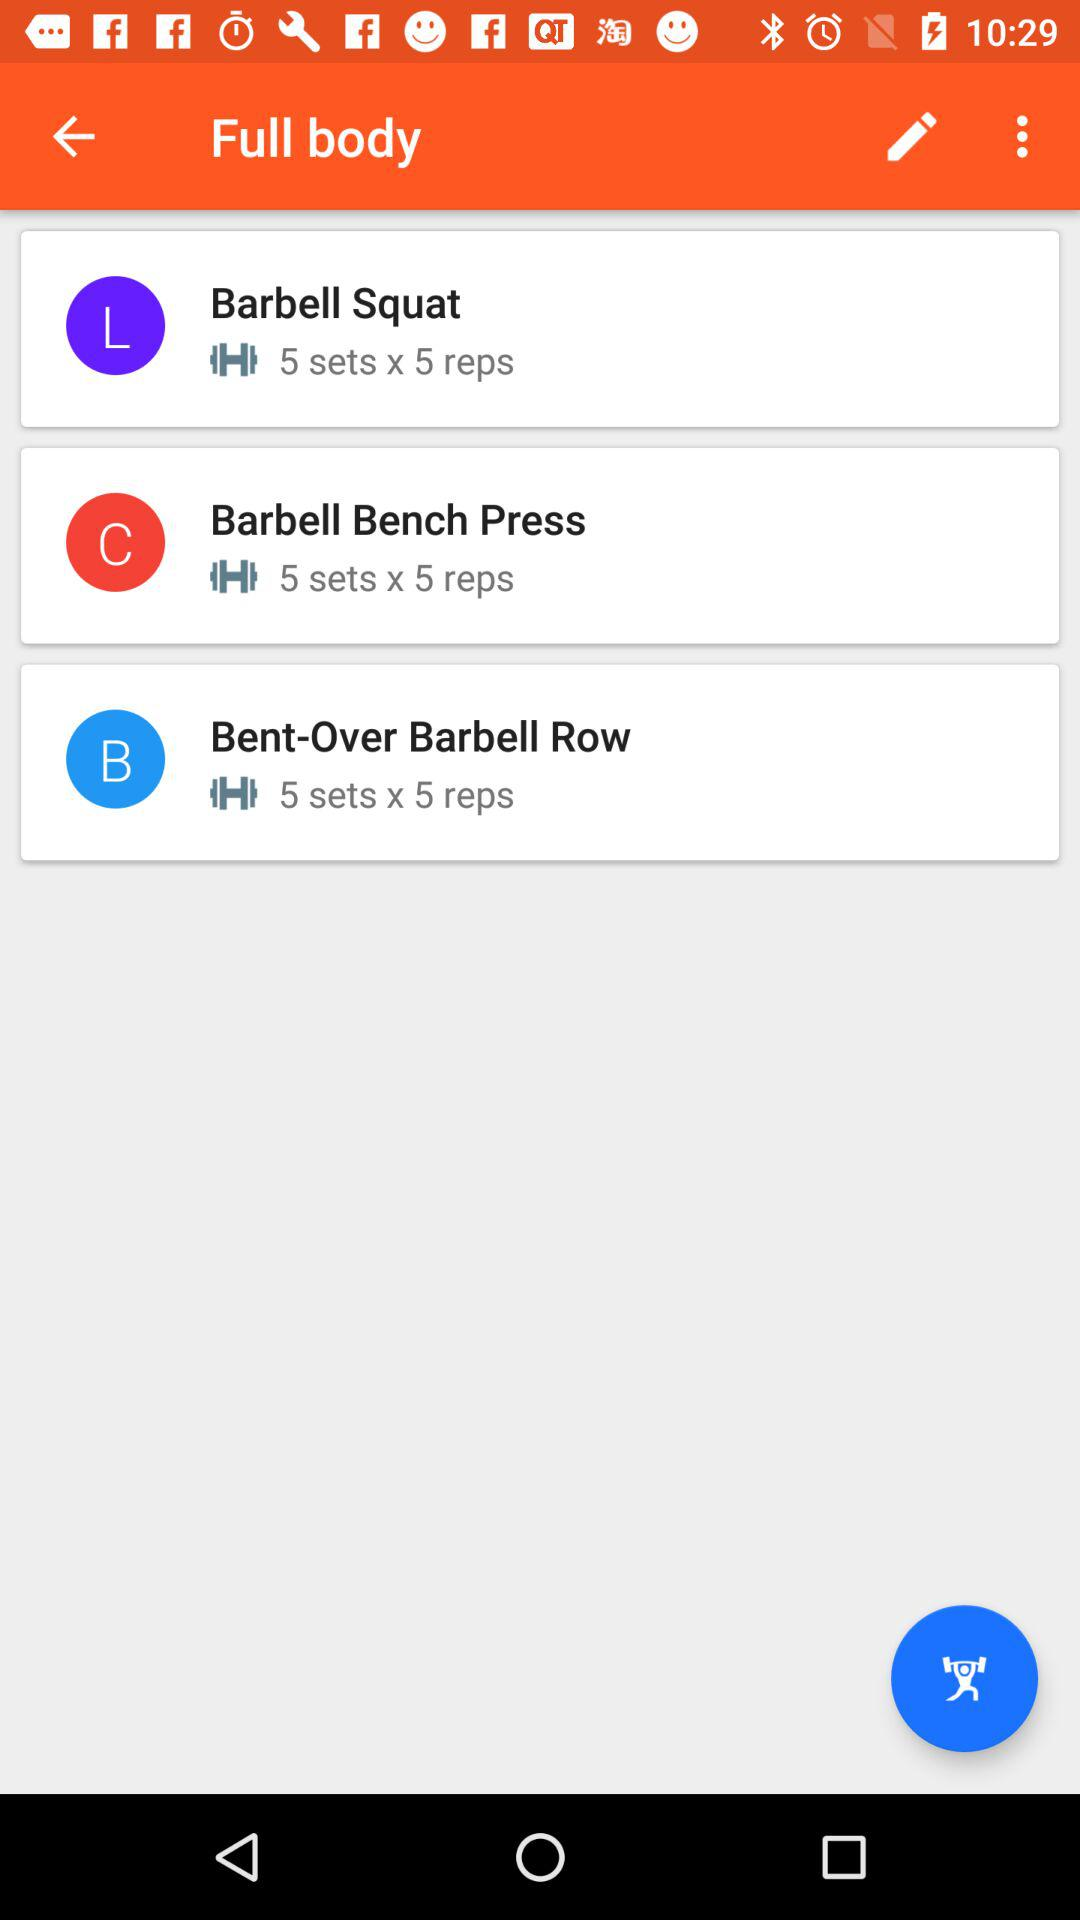How much time is allowed to complete one set?
When the provided information is insufficient, respond with <no answer>. <no answer> 